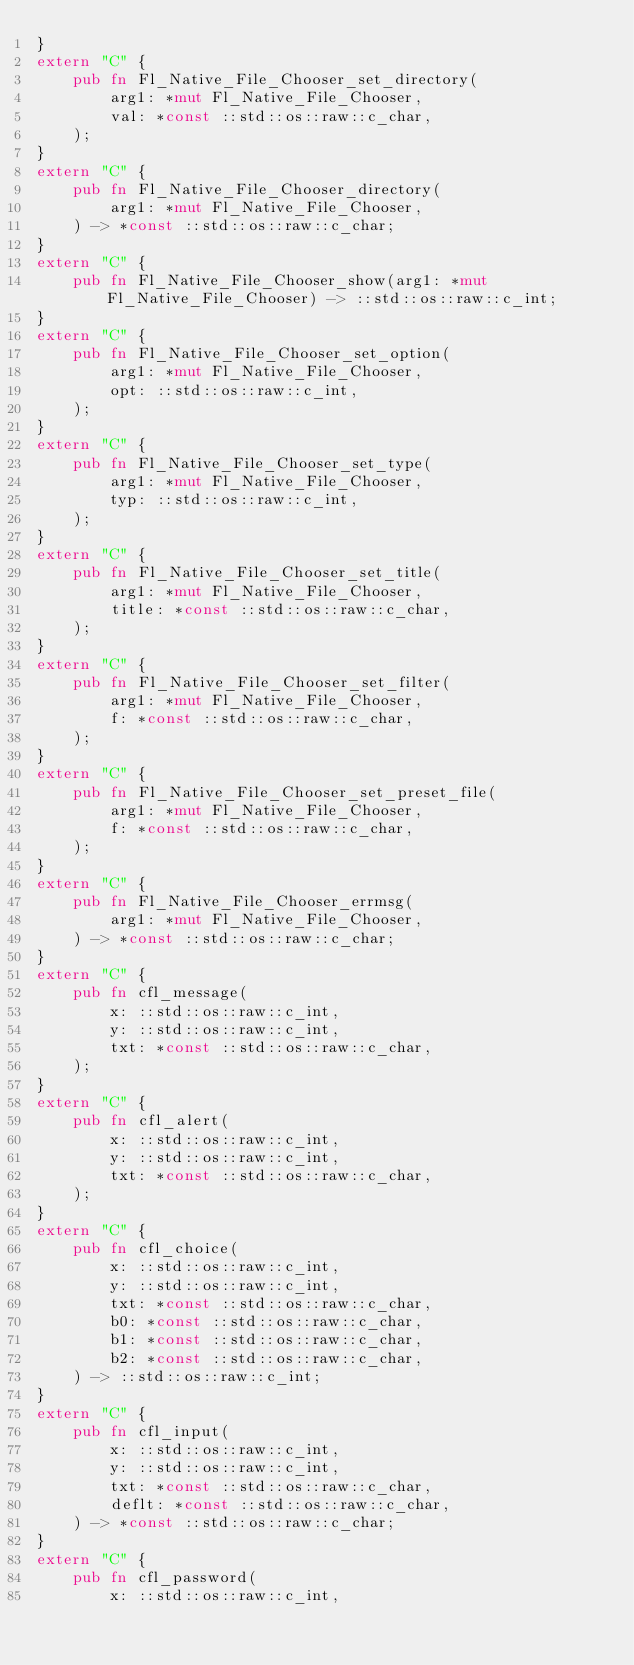<code> <loc_0><loc_0><loc_500><loc_500><_Rust_>}
extern "C" {
    pub fn Fl_Native_File_Chooser_set_directory(
        arg1: *mut Fl_Native_File_Chooser,
        val: *const ::std::os::raw::c_char,
    );
}
extern "C" {
    pub fn Fl_Native_File_Chooser_directory(
        arg1: *mut Fl_Native_File_Chooser,
    ) -> *const ::std::os::raw::c_char;
}
extern "C" {
    pub fn Fl_Native_File_Chooser_show(arg1: *mut Fl_Native_File_Chooser) -> ::std::os::raw::c_int;
}
extern "C" {
    pub fn Fl_Native_File_Chooser_set_option(
        arg1: *mut Fl_Native_File_Chooser,
        opt: ::std::os::raw::c_int,
    );
}
extern "C" {
    pub fn Fl_Native_File_Chooser_set_type(
        arg1: *mut Fl_Native_File_Chooser,
        typ: ::std::os::raw::c_int,
    );
}
extern "C" {
    pub fn Fl_Native_File_Chooser_set_title(
        arg1: *mut Fl_Native_File_Chooser,
        title: *const ::std::os::raw::c_char,
    );
}
extern "C" {
    pub fn Fl_Native_File_Chooser_set_filter(
        arg1: *mut Fl_Native_File_Chooser,
        f: *const ::std::os::raw::c_char,
    );
}
extern "C" {
    pub fn Fl_Native_File_Chooser_set_preset_file(
        arg1: *mut Fl_Native_File_Chooser,
        f: *const ::std::os::raw::c_char,
    );
}
extern "C" {
    pub fn Fl_Native_File_Chooser_errmsg(
        arg1: *mut Fl_Native_File_Chooser,
    ) -> *const ::std::os::raw::c_char;
}
extern "C" {
    pub fn cfl_message(
        x: ::std::os::raw::c_int,
        y: ::std::os::raw::c_int,
        txt: *const ::std::os::raw::c_char,
    );
}
extern "C" {
    pub fn cfl_alert(
        x: ::std::os::raw::c_int,
        y: ::std::os::raw::c_int,
        txt: *const ::std::os::raw::c_char,
    );
}
extern "C" {
    pub fn cfl_choice(
        x: ::std::os::raw::c_int,
        y: ::std::os::raw::c_int,
        txt: *const ::std::os::raw::c_char,
        b0: *const ::std::os::raw::c_char,
        b1: *const ::std::os::raw::c_char,
        b2: *const ::std::os::raw::c_char,
    ) -> ::std::os::raw::c_int;
}
extern "C" {
    pub fn cfl_input(
        x: ::std::os::raw::c_int,
        y: ::std::os::raw::c_int,
        txt: *const ::std::os::raw::c_char,
        deflt: *const ::std::os::raw::c_char,
    ) -> *const ::std::os::raw::c_char;
}
extern "C" {
    pub fn cfl_password(
        x: ::std::os::raw::c_int,</code> 